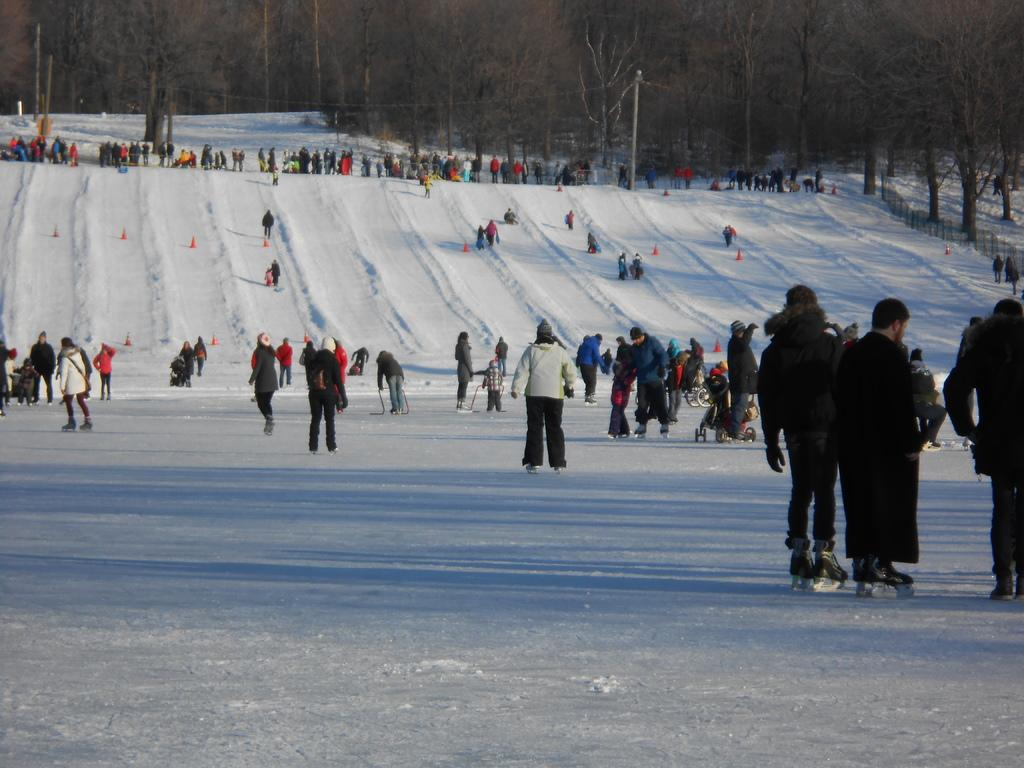What are the people in the image doing? There are people skating and walking on the snow in the image. What objects can be seen in the image that are related to safety or guidance? There are poles, traffic cones, and railing in the image. What type of natural environment is visible in the image? There are trees in the image. What historical event is being commemorated by the people wearing collars in the image? There is no mention of collars or any historical event in the image. The people are simply skating and walking on the snow. Can you describe the mist that is covering the trees in the image? There is no mist present in the image; the trees are clearly visible. 